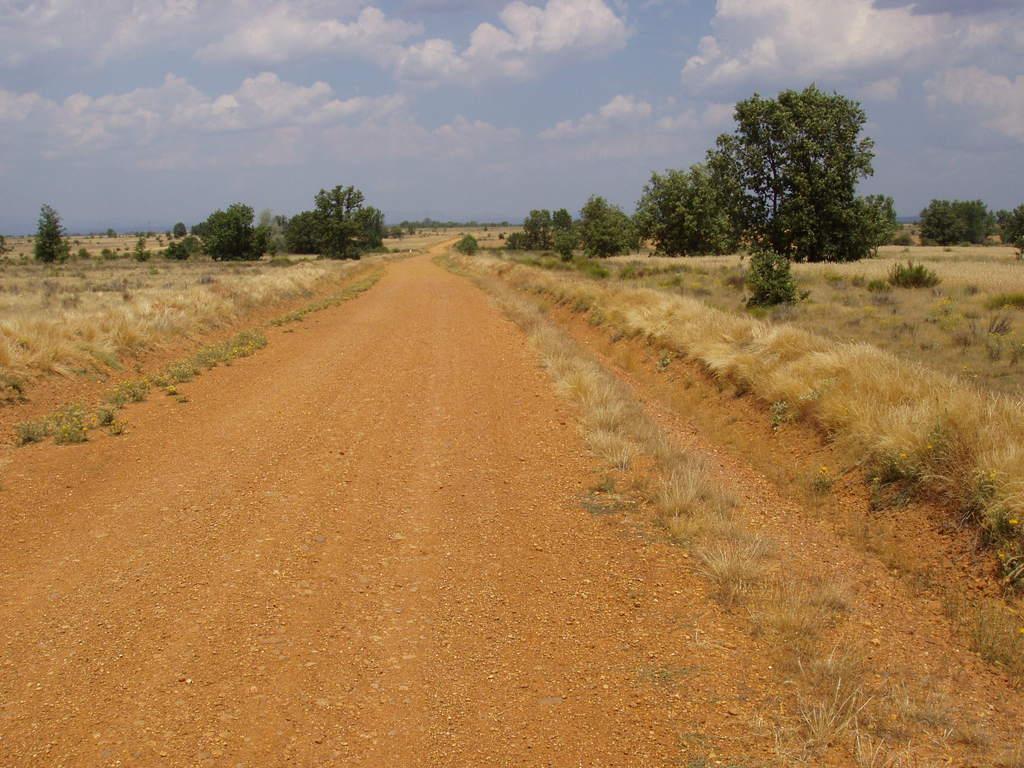Could you give a brief overview of what you see in this image? In this image there are many trees and also grass. At the top there is sky with clouds and at the bottom there is road. 